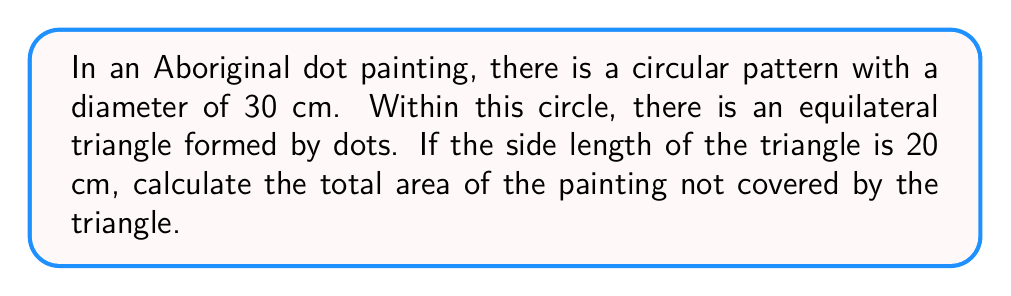Could you help me with this problem? Let's approach this step-by-step:

1. Calculate the area of the circular pattern:
   $$A_{circle} = \pi r^2 = \pi (\frac{d}{2})^2 = \pi (\frac{30}{2})^2 = 225\pi \text{ cm}^2$$

2. Calculate the area of the equilateral triangle:
   First, we need to find the height of the triangle:
   $$h = \frac{\sqrt{3}}{2} \cdot s = \frac{\sqrt{3}}{2} \cdot 20 = 10\sqrt{3} \text{ cm}$$
   Now, we can calculate the area:
   $$A_{triangle} = \frac{1}{2} \cdot b \cdot h = \frac{1}{2} \cdot 20 \cdot 10\sqrt{3} = 100\sqrt{3} \text{ cm}^2$$

3. Calculate the area not covered by the triangle:
   $$A_{not covered} = A_{circle} - A_{triangle} = 225\pi - 100\sqrt{3} \text{ cm}^2$$

[asy]
unitsize(0.1cm);
fill(circle((0,0),15), rgb(0.9,0.9,0.9));
draw(circle((0,0),15));
pair A = (10*sqrt(3),-10), B = (-10*sqrt(3),-10), C = (0,20);
fill(A--B--C--cycle, rgb(0.7,0.7,0.7));
draw(A--B--C--cycle);
label("30 cm", (15,0), E);
label("20 cm", (0,-10), S);
[/asy]
Answer: $225\pi - 100\sqrt{3} \text{ cm}^2$ 